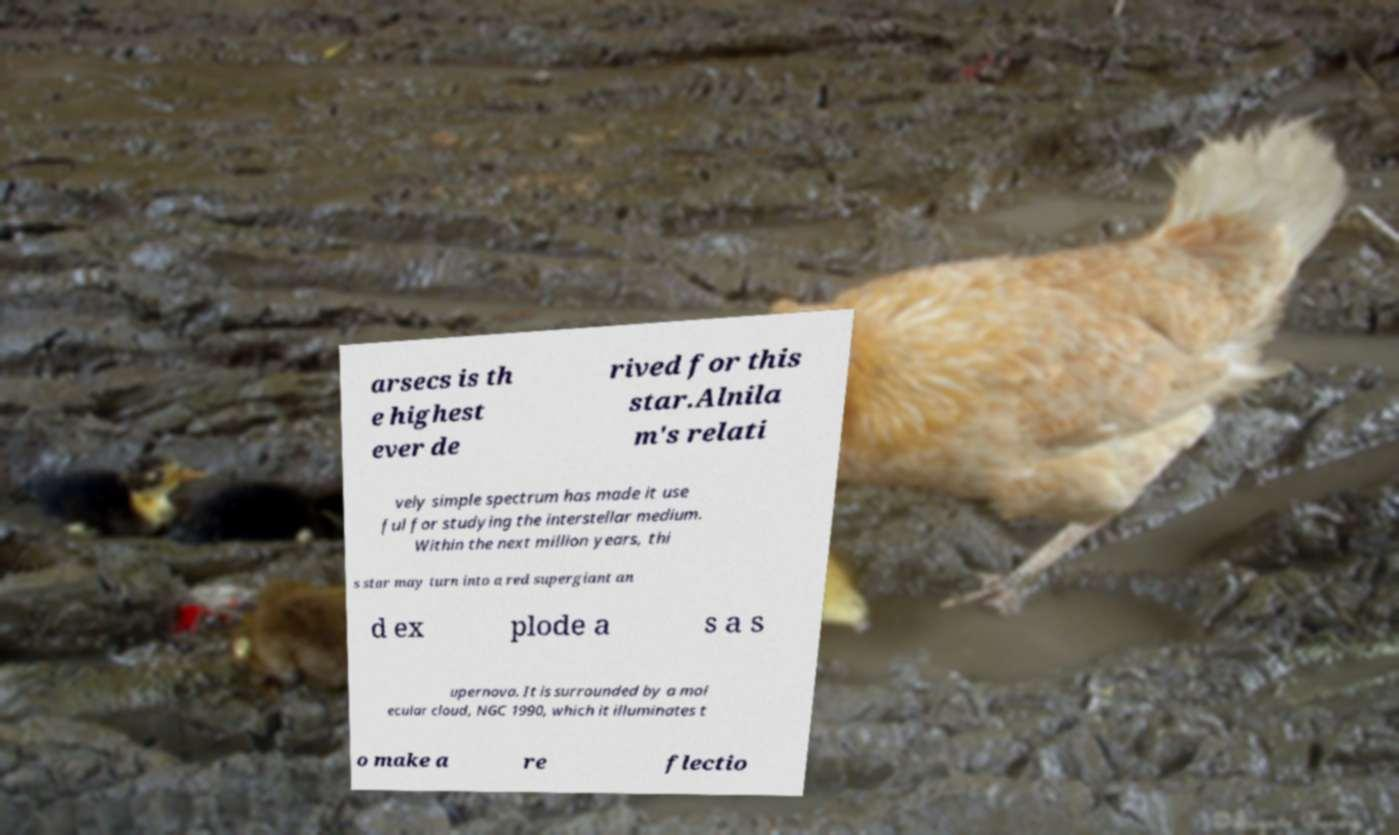Could you extract and type out the text from this image? arsecs is th e highest ever de rived for this star.Alnila m's relati vely simple spectrum has made it use ful for studying the interstellar medium. Within the next million years, thi s star may turn into a red supergiant an d ex plode a s a s upernova. It is surrounded by a mol ecular cloud, NGC 1990, which it illuminates t o make a re flectio 